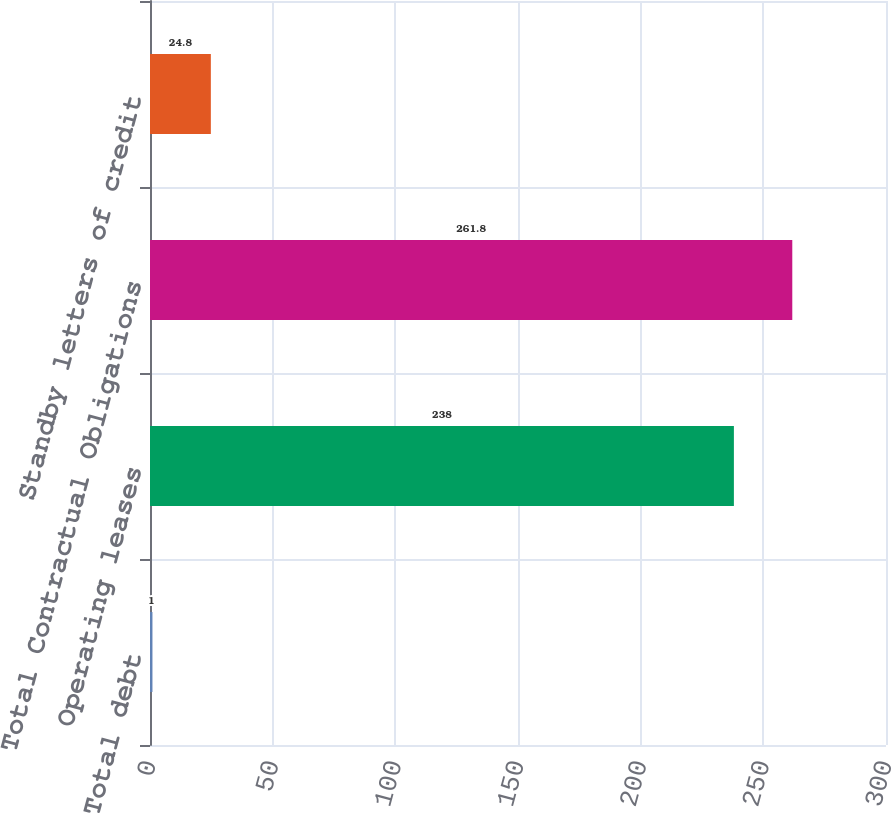Convert chart to OTSL. <chart><loc_0><loc_0><loc_500><loc_500><bar_chart><fcel>Total debt<fcel>Operating leases<fcel>Total Contractual Obligations<fcel>Standby letters of credit<nl><fcel>1<fcel>238<fcel>261.8<fcel>24.8<nl></chart> 